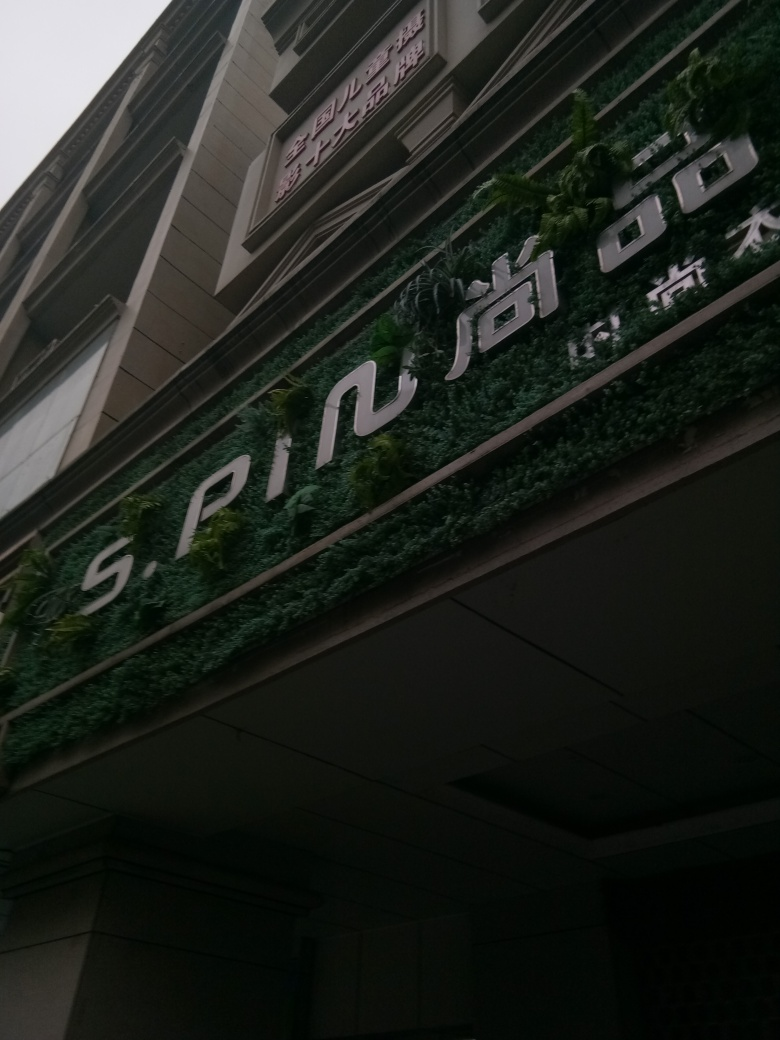What does the presence of a vertical garden imply about the building's environmental considerations? The incorporation of a vertical garden on the building's exterior indicates a commitment to sustainability and green architecture. It suggests an effort to integrate natural elements into urban structures, reducing the carbon footprint, improving air quality, and contributing to overall ecological benefits within the urban space. 